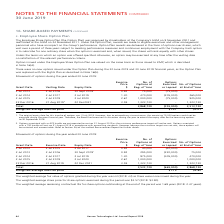According to Hansen Technologies's financial document, What was the weighted average share price for share options exercised during the period? $3.57 (2018: $3.90).. The document states: "for share options exercised during the period was $3.57 (2018: $3.90)...." Also, can you calculate: What was the total weighted exercise cost for all options exercised or lapsed? Based on the calculation: 665,000 * $1.15 , the result is 764750. This is based on the information: "Total 3,533,730 (665,000) 2,868,730 Weighted average exercise price $1.15 $2.82..." The key data points involved are: 1.15, 665,000. Also, What was the weighted average remaining contractual life for share options outstanding at the end of period? 1.68 years (2018: 2.47 years).. The document states: "e options outstanding at the end of the period was 1.68 years (2018: 2.47 years)...." Also, Why was the weighted average fair value of options granted during the year was nil? The weighted average fair value of options granted during the year was nil (2018: nil) as there were none issued during the year.. The document states: "The weighted average fair value of options granted during the year was nil (2018: nil) as there were none issued during the year...." Also, can you calculate: What was the total percentage change in exercise price between 2014 and 2016? To answer this question, I need to perform calculations using the financial data. The calculation is: (3.59 - 1.30) / 1.30 , which equals 176.15 (percentage). This is based on the information: "22 Dec 2016 31 Aug 2019 2 22 Dec2021 3.59 1,323,730 - 1,323,730 2 Jul 2014 2 Jul 2017 2 Jul 2019 1.30 470,000 (205,000) 265,000..." The key data points involved are: 1.30, 3.59. Additionally, What was the options' exercise date with the greatest number of options exercised or lapsed? According to the financial document, 2 Jul 2017. The relevant text states: "2 Jul 2012 2 Jul 2015 2 Jul 2017 0.92 40,000 (40,000) -..." 